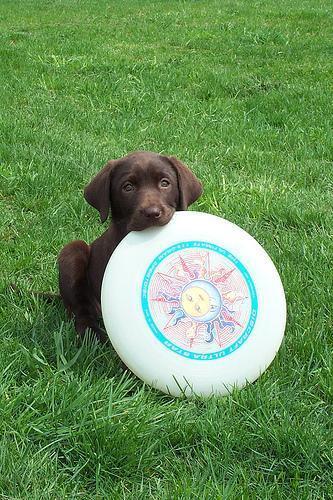How many dogs are in the picture?
Give a very brief answer. 1. 